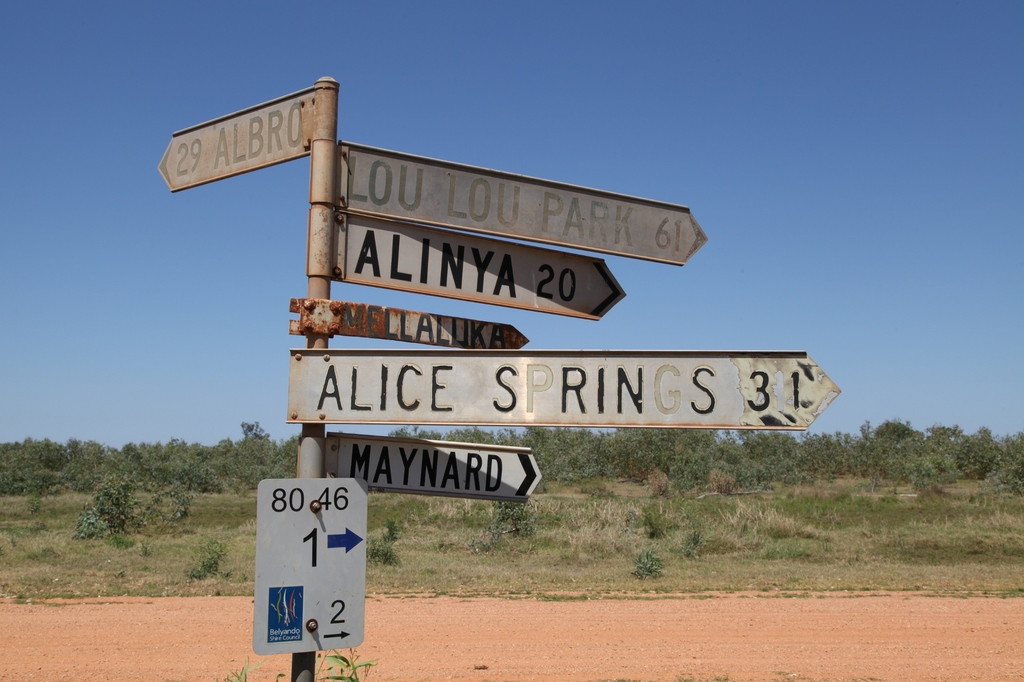What is this photo about? The photo depicts a weathered and rusted signpost located in the Australian outback, which serves as a directional guide to several destinations. Notably, it points to 'Alice Springs' and other lesser-known locales like 'Lou Lou Park' and 'Ntyalika', providing travelers with vital guidance in this remote terrain. Each sign is distinctly aged, hinting at the harsh environmental conditions they endure. The presence of the kangaroo sign also subtly reminds viewers of the native wildlife, characteristic of the Australian landscape. The clear skies and sparse vegetation highlight the typical arid environment of the region, emphasizing the solitary yet critical role of this signpost in navigating such a vast and rugged area. 